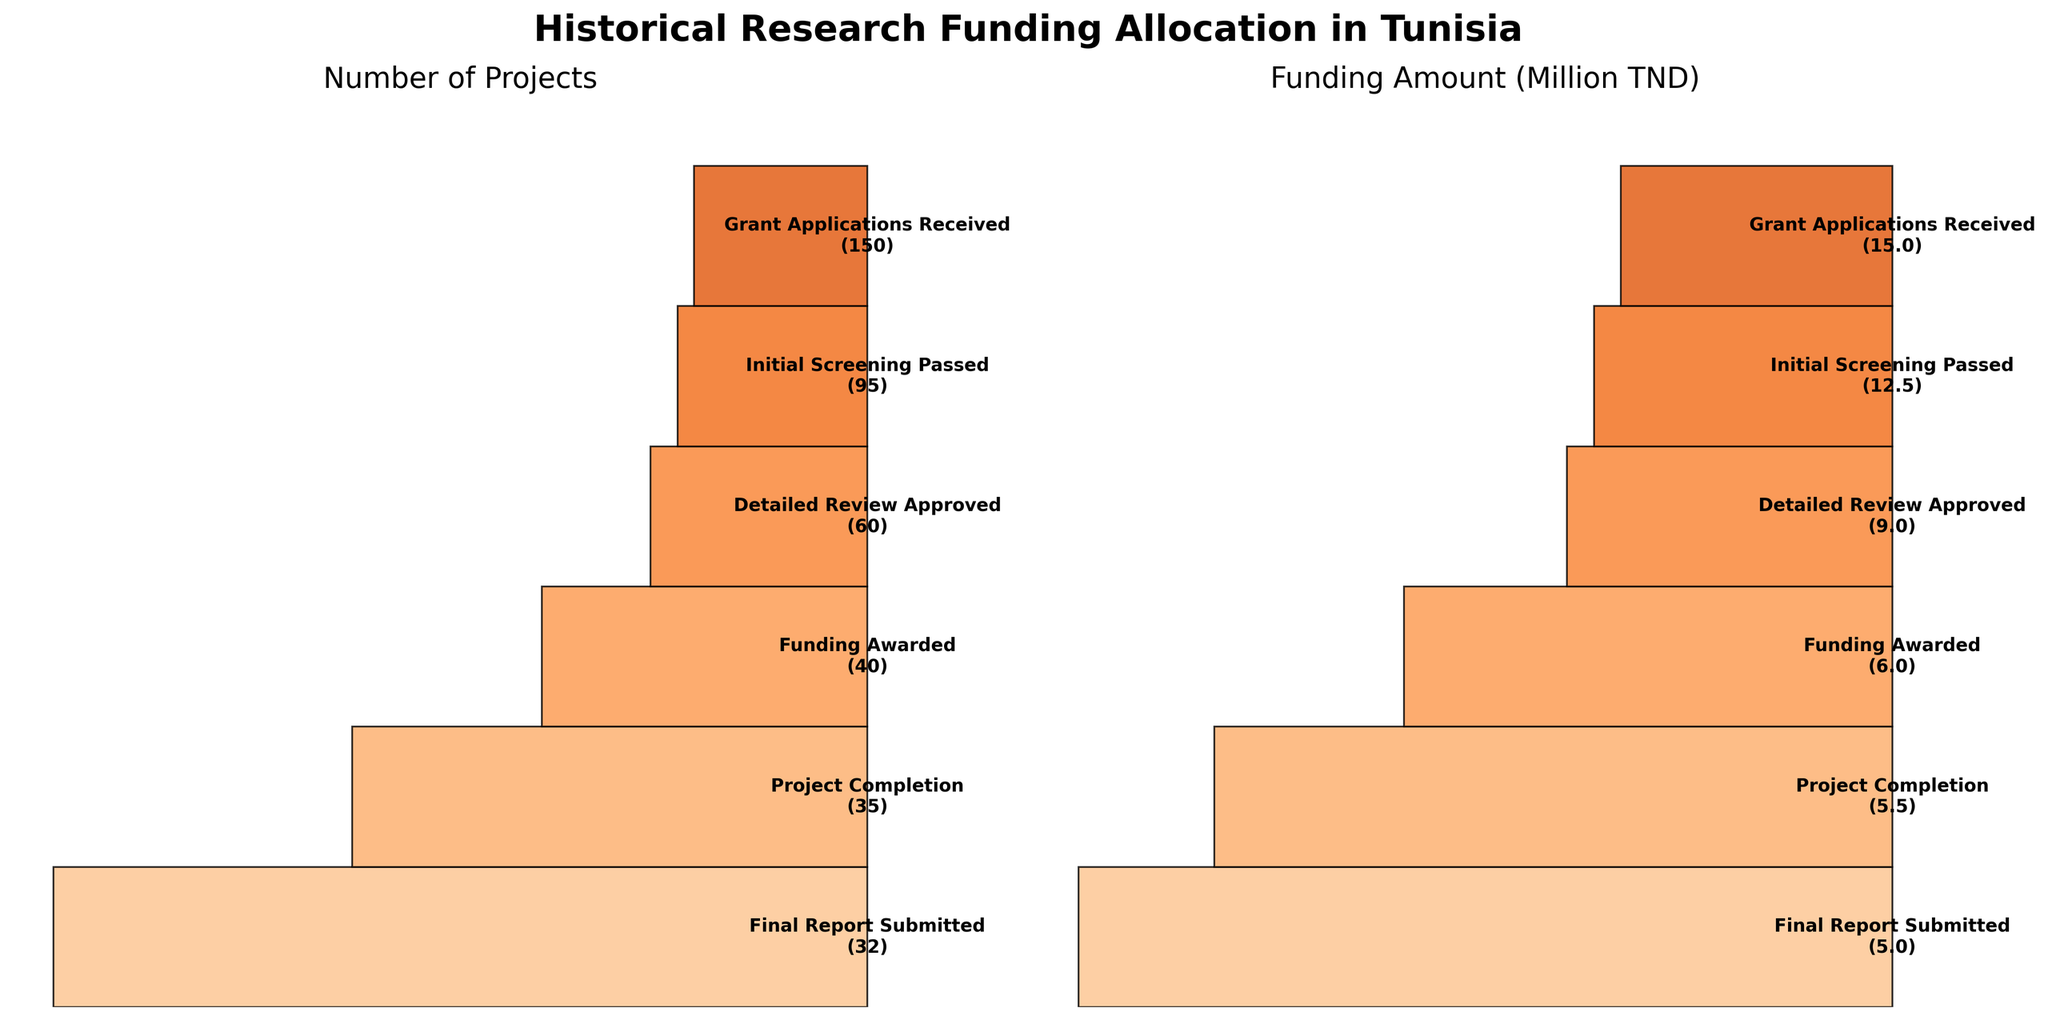What is the title of the plot? The title of the plot is "Historical Research Funding Allocation in Tunisia." This is captured from the main heading at the top of the figure.
Answer: Historical Research Funding Allocation in Tunisia How many stages are there in the funnel chart? The number of stages can be counted directly from the funnel. Each stage corresponds to a level in the funnel graphic: Grant Applications Received, Initial Screening Passed, Detailed Review Approved, Funding Awarded, Project Completion, and Final Report Submitted.
Answer: 6 Which stage has the largest reduction in the number of projects? The largest reduction can be found by checking where the funnel width decreases the most between stages. Between "Grant Applications Received" (150) and "Initial Screening Passed" (95), the reduction is 55 projects, the largest drop compared to other stages.
Answer: From Grant Applications Received to Initial Screening Passed What is the total funding amount across all stages? Sum the funding amounts across all stages: 15,000,000 + 12,500,000 + 9,000,000 + 6,000,000 + 5,500,000 + 5,000,000 = 53,000,000 TND.
Answer: 53,000,000 TND What is the difference in funding amount between "Funding Awarded" and "Project Completion"? Subtract the "Project Completion" funding (5,500,000 TND) from the "Funding Awarded" funding (6,000,000 TND): 6,000,000 - 5,500,000 = 500,000 TND.
Answer: 500,000 TND How many projects reached "Final Report Submitted"? Look at the value indicated in the funnel at the "Final Report Submitted" stage. It shows 32 projects.
Answer: 32 What percentage of projects that received funding were completed? Compute the percentage by dividing the number of projects at "Project Completion" (35) by the number of projects at "Funding Awarded" (40) and multiplying by 100: (35 / 40) * 100 = 87.5%.
Answer: 87.5% What is the ratio of the number of projects received at the initial screening to the final report submission? Divide the number of projects at the "Initial Screening Passed" stage (95) by the number of projects at the "Final Report Submitted" stage (32): 95 / 32 ≈ 2.97.
Answer: 2.97 How does the number of projects change from “Detailed Review Approved” to “Final Report Submitted”? Calculate the change by subtracting the number of projects at "Final Report Submitted" (32) from "Detailed Review Approved" (60): 60 - 32 = 28 projects.
Answer: Drops by 28 projects What is the funding difference between the highest and lowest stages? Determine the difference by subtracting the funding at the "Final Report Submitted" stage (5,000,000 TND) from the "Grant Applications Received" stage (15,000,000 TND): 15,000,000 - 5,000,000 = 10,000,000 TND.
Answer: 10,000,000 TND 